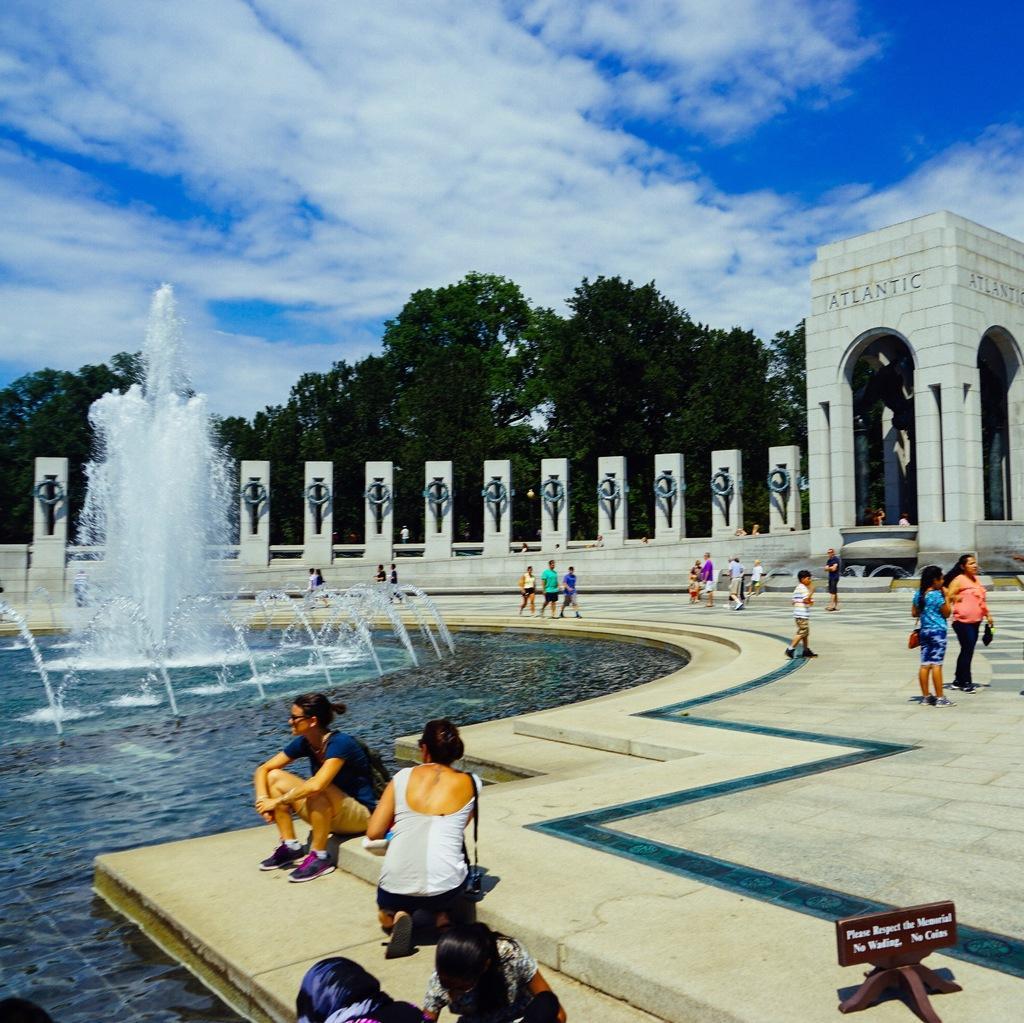In one or two sentences, can you explain what this image depicts? In this picture we can see some people are standing, some people are walking and some people are sitting and a woman is in squat position. Behind the people there is a fountain, pillar and an arch. Behind the arch there are trees and the sky. On the right side of the people there is an object on the path. 